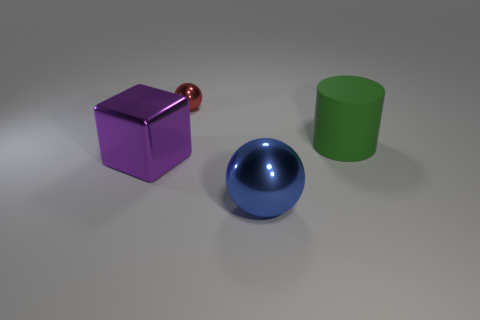Add 3 big cyan cylinders. How many objects exist? 7 Subtract 1 cubes. How many cubes are left? 0 Subtract all red balls. How many balls are left? 1 Add 4 tiny red shiny objects. How many tiny red shiny objects are left? 5 Add 4 blue metal things. How many blue metal things exist? 5 Subtract 0 brown spheres. How many objects are left? 4 Subtract all green cubes. Subtract all cyan spheres. How many cubes are left? 1 Subtract all tiny cyan rubber blocks. Subtract all shiny objects. How many objects are left? 1 